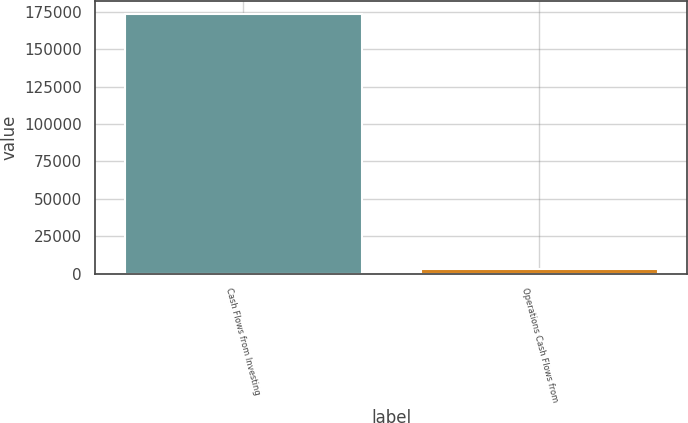Convert chart to OTSL. <chart><loc_0><loc_0><loc_500><loc_500><bar_chart><fcel>Cash Flows from Investing<fcel>Operations Cash Flows from<nl><fcel>173507<fcel>2864<nl></chart> 